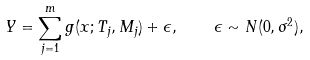<formula> <loc_0><loc_0><loc_500><loc_500>Y = \sum _ { j = 1 } ^ { m } g ( x ; T _ { j } , M _ { j } ) + \epsilon , \quad \epsilon \sim N ( 0 , \sigma ^ { 2 } ) ,</formula> 